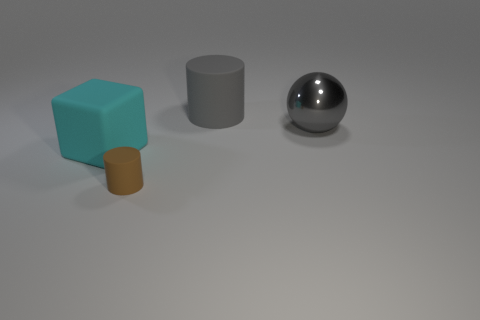Add 2 balls. How many objects exist? 6 Subtract all blocks. How many objects are left? 3 Subtract 1 gray balls. How many objects are left? 3 Subtract all tiny red balls. Subtract all gray cylinders. How many objects are left? 3 Add 2 brown matte objects. How many brown matte objects are left? 3 Add 2 purple shiny cylinders. How many purple shiny cylinders exist? 2 